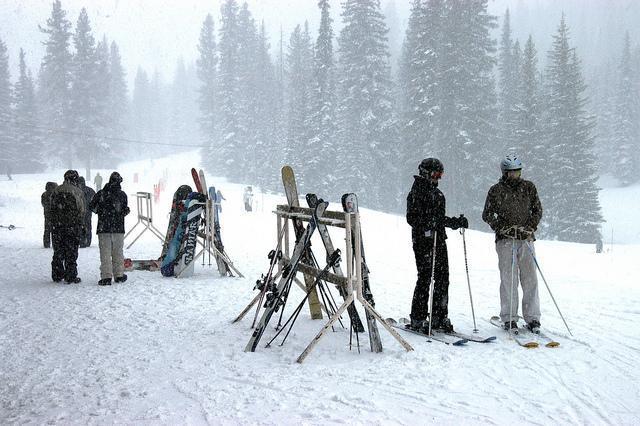How many people are visible?
Give a very brief answer. 4. 